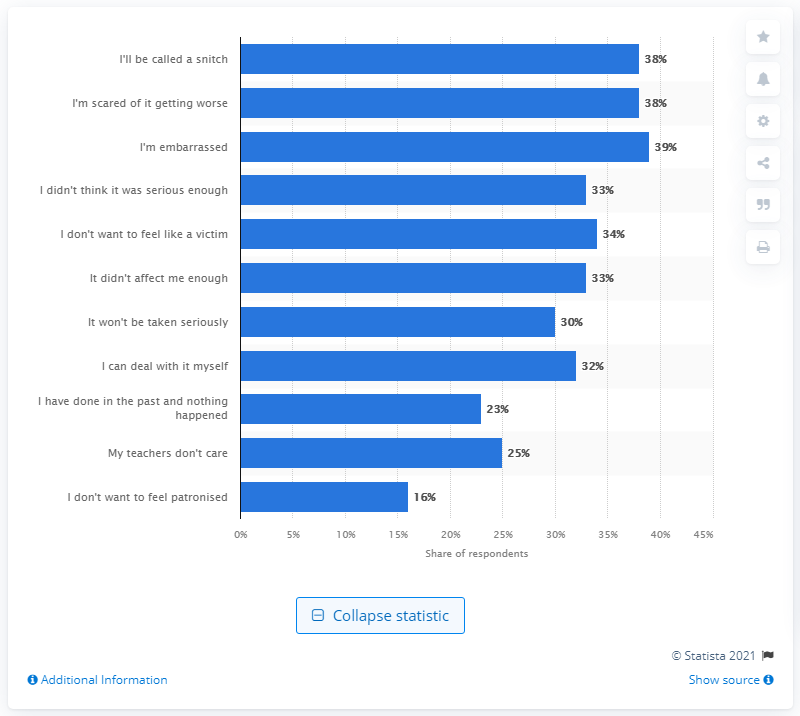Highlight a few significant elements in this photo. According to the victims surveyed, 38% expressed fear of being labeled a snitch. 